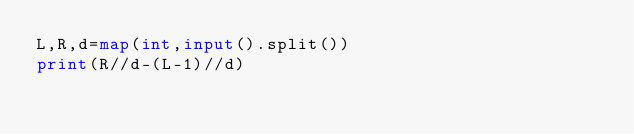Convert code to text. <code><loc_0><loc_0><loc_500><loc_500><_Python_>L,R,d=map(int,input().split())
print(R//d-(L-1)//d)</code> 